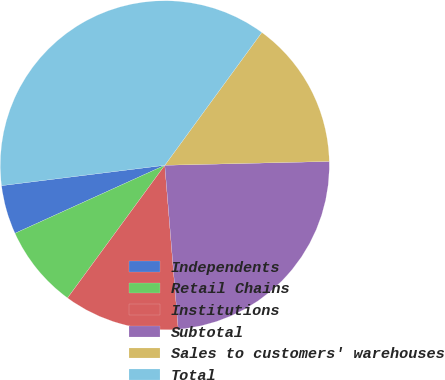Convert chart to OTSL. <chart><loc_0><loc_0><loc_500><loc_500><pie_chart><fcel>Independents<fcel>Retail Chains<fcel>Institutions<fcel>Subtotal<fcel>Sales to customers' warehouses<fcel>Total<nl><fcel>4.81%<fcel>8.15%<fcel>11.37%<fcel>24.07%<fcel>14.59%<fcel>37.02%<nl></chart> 